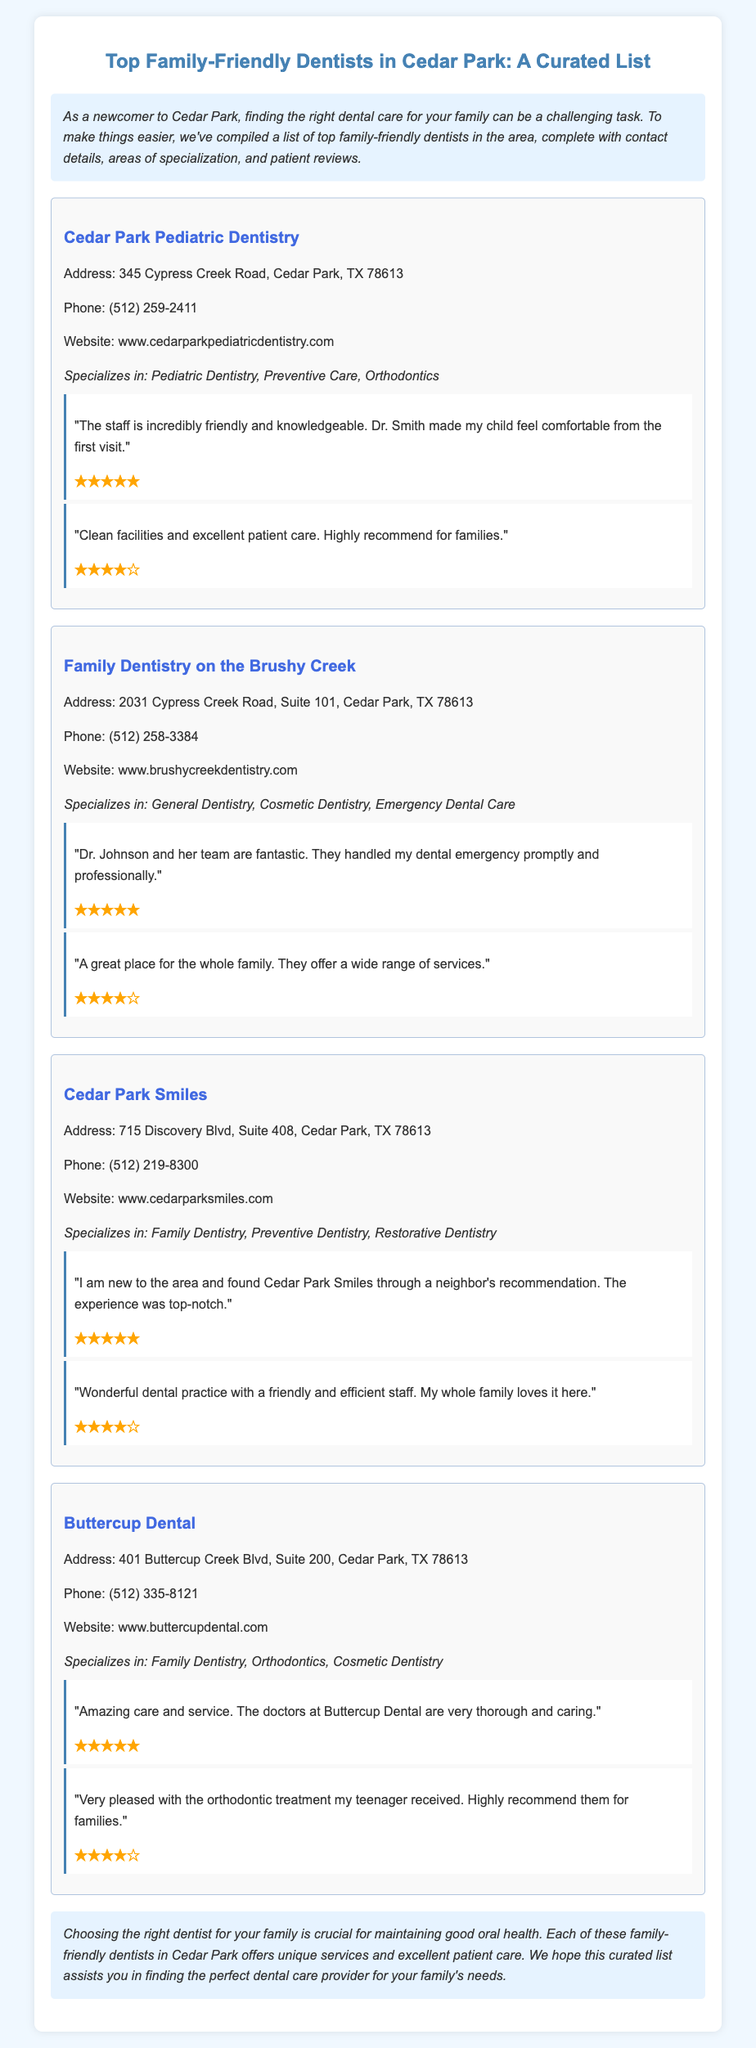What is the address of Cedar Park Pediatric Dentistry? The address is listed in the contact details section for Cedar Park Pediatric Dentistry.
Answer: 345 Cypress Creek Road, Cedar Park, TX 78613 How many dentists' names are mentioned in the document? There are four dentists listed in the document.
Answer: Four What is the specialty of Family Dentistry on the Brushy Creek? The specialty is found in the specializations section for Family Dentistry on the Brushy Creek.
Answer: General Dentistry, Cosmetic Dentistry, Emergency Dental Care Which dentist has received a five-star rating for excellent patient care? Several reviews mention five-star ratings for different dentists, but patient care is highlighted for Buttercup Dental.
Answer: Buttercup Dental What is the phone number for Cedar Park Smiles? The phone number is indicated in the contact details section for Cedar Park Smiles.
Answer: (512) 219-8300 Which dentist specializes in orthodontics and cosmetic dentistry? The specializations section shows that Buttercup Dental specializes in orthodontics and cosmetic dentistry.
Answer: Buttercup Dental What are the areas of specialization for Cedar Park Smiles? The areas of specialization are listed in the specializations section of Cedar Park Smiles.
Answer: Family Dentistry, Preventive Dentistry, Restorative Dentistry How many reviews are there for Family Dentistry on the Brushy Creek? The count of reviews is found in the reviews section of Family Dentistry on the Brushy Creek.
Answer: Two What is the overall theme of the document? The overall theme is explained in the introduction and conclusion sections.
Answer: Finding family-friendly dentists in Cedar Park 